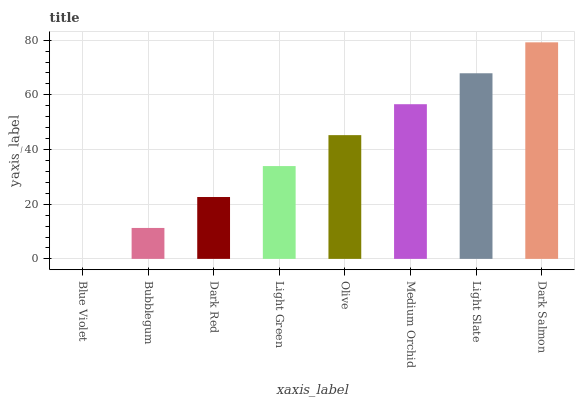Is Blue Violet the minimum?
Answer yes or no. Yes. Is Dark Salmon the maximum?
Answer yes or no. Yes. Is Bubblegum the minimum?
Answer yes or no. No. Is Bubblegum the maximum?
Answer yes or no. No. Is Bubblegum greater than Blue Violet?
Answer yes or no. Yes. Is Blue Violet less than Bubblegum?
Answer yes or no. Yes. Is Blue Violet greater than Bubblegum?
Answer yes or no. No. Is Bubblegum less than Blue Violet?
Answer yes or no. No. Is Olive the high median?
Answer yes or no. Yes. Is Light Green the low median?
Answer yes or no. Yes. Is Dark Red the high median?
Answer yes or no. No. Is Medium Orchid the low median?
Answer yes or no. No. 